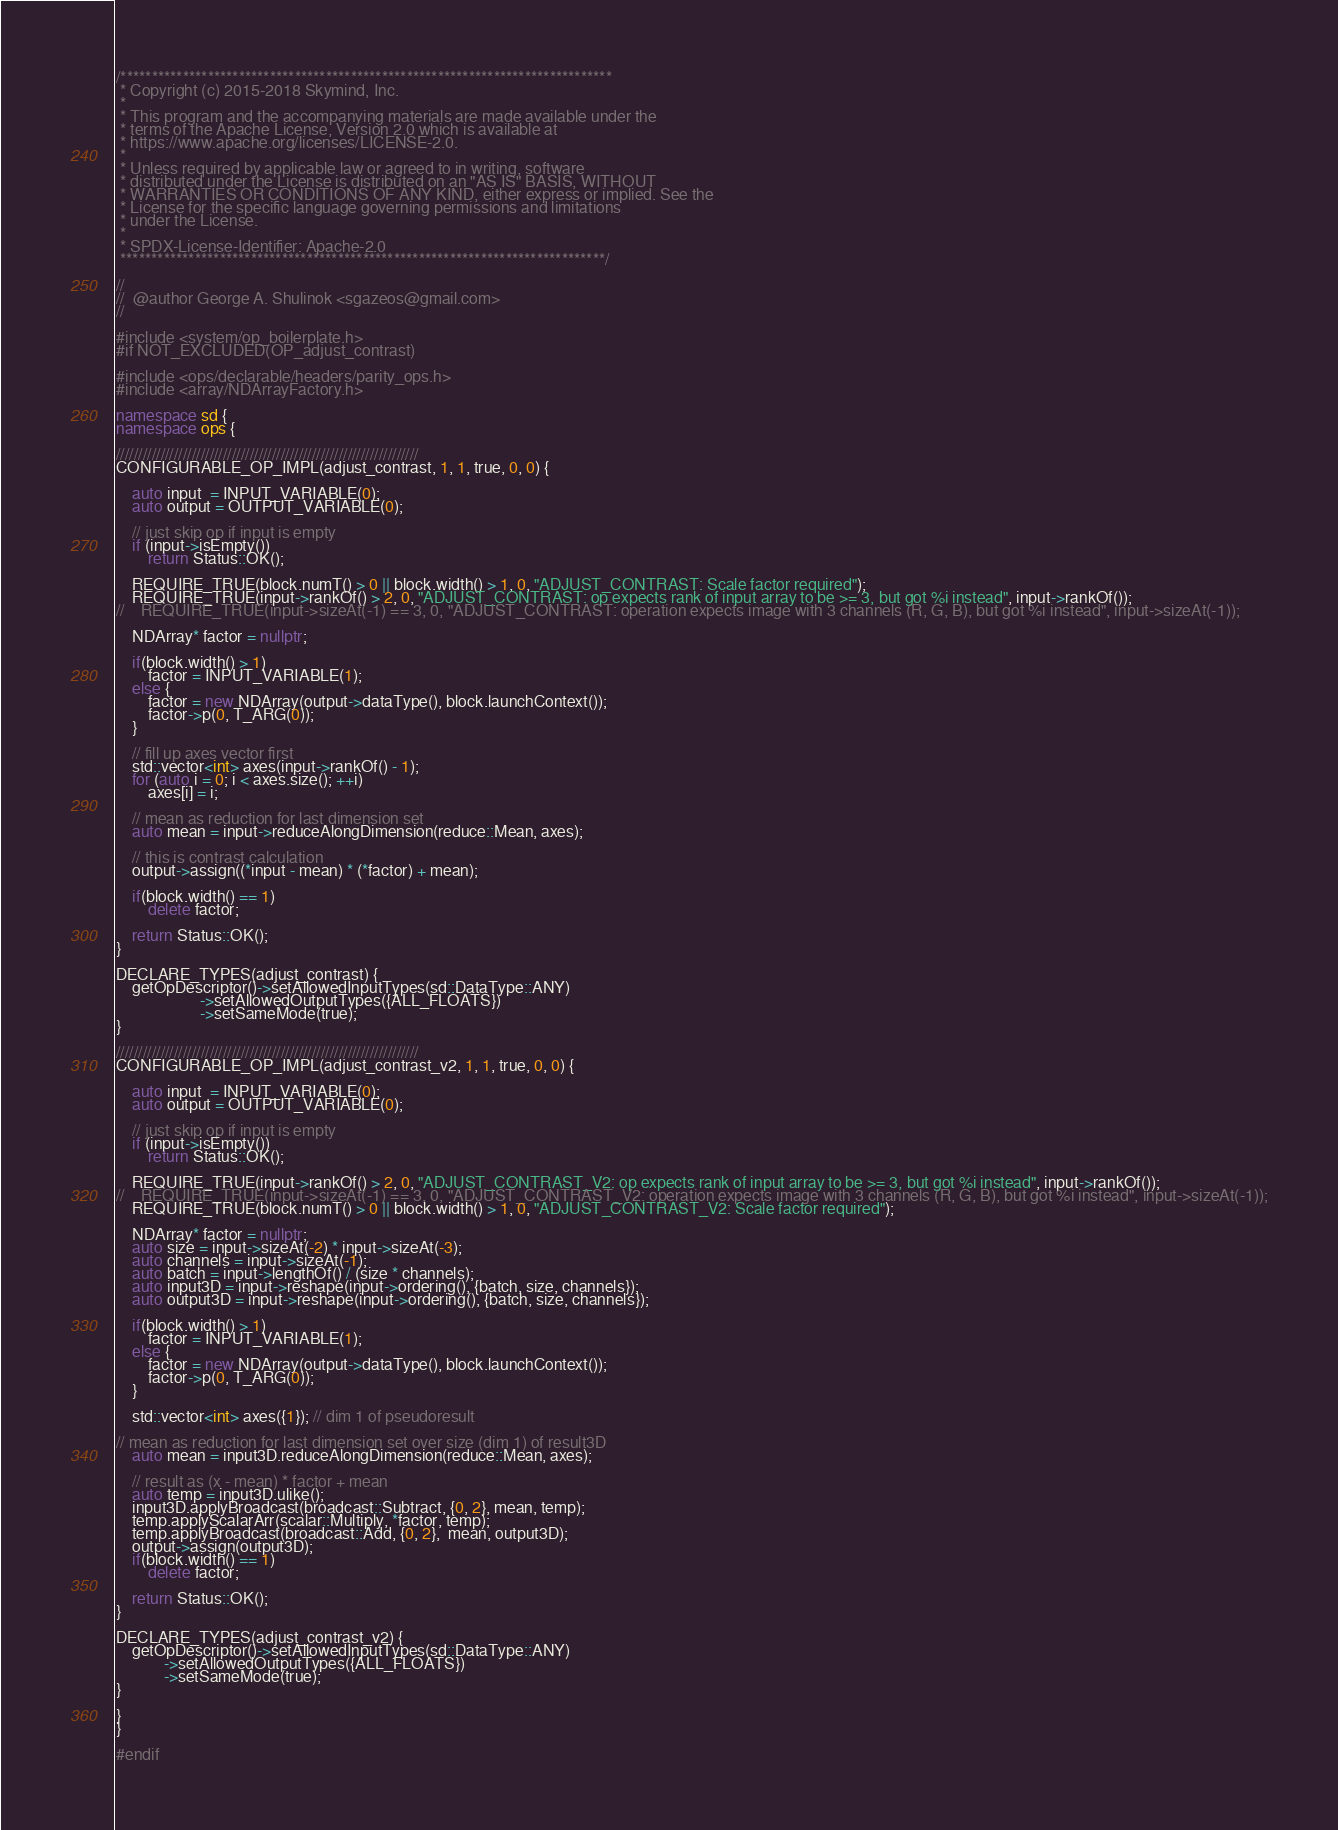Convert code to text. <code><loc_0><loc_0><loc_500><loc_500><_C++_>/*******************************************************************************
 * Copyright (c) 2015-2018 Skymind, Inc.
 *
 * This program and the accompanying materials are made available under the
 * terms of the Apache License, Version 2.0 which is available at
 * https://www.apache.org/licenses/LICENSE-2.0.
 *
 * Unless required by applicable law or agreed to in writing, software
 * distributed under the License is distributed on an "AS IS" BASIS, WITHOUT
 * WARRANTIES OR CONDITIONS OF ANY KIND, either express or implied. See the
 * License for the specific language governing permissions and limitations
 * under the License.
 *
 * SPDX-License-Identifier: Apache-2.0
 ******************************************************************************/

//
//  @author George A. Shulinok <sgazeos@gmail.com>
//

#include <system/op_boilerplate.h>
#if NOT_EXCLUDED(OP_adjust_contrast)

#include <ops/declarable/headers/parity_ops.h>
#include <array/NDArrayFactory.h>

namespace sd {
namespace ops {

////////////////////////////////////////////////////////////////////
CONFIGURABLE_OP_IMPL(adjust_contrast, 1, 1, true, 0, 0) {

    auto input  = INPUT_VARIABLE(0);
    auto output = OUTPUT_VARIABLE(0);

    // just skip op if input is empty
    if (input->isEmpty())
        return Status::OK();

    REQUIRE_TRUE(block.numT() > 0 || block.width() > 1, 0, "ADJUST_CONTRAST: Scale factor required");
    REQUIRE_TRUE(input->rankOf() > 2, 0, "ADJUST_CONTRAST: op expects rank of input array to be >= 3, but got %i instead", input->rankOf());
//    REQUIRE_TRUE(input->sizeAt(-1) == 3, 0, "ADJUST_CONTRAST: operation expects image with 3 channels (R, G, B), but got %i instead", input->sizeAt(-1));

    NDArray* factor = nullptr;

    if(block.width() > 1)
        factor = INPUT_VARIABLE(1);
    else {
        factor = new NDArray(output->dataType(), block.launchContext());
        factor->p(0, T_ARG(0));
    }

    // fill up axes vector first
    std::vector<int> axes(input->rankOf() - 1);
    for (auto i = 0; i < axes.size(); ++i)
        axes[i] = i;

    // mean as reduction for last dimension set
    auto mean = input->reduceAlongDimension(reduce::Mean, axes);

    // this is contrast calculation
    output->assign((*input - mean) * (*factor) + mean);

    if(block.width() == 1)
        delete factor;

    return Status::OK();
}

DECLARE_TYPES(adjust_contrast) {
    getOpDescriptor()->setAllowedInputTypes(sd::DataType::ANY)
                     ->setAllowedOutputTypes({ALL_FLOATS})
                     ->setSameMode(true);
}

////////////////////////////////////////////////////////////////////
CONFIGURABLE_OP_IMPL(adjust_contrast_v2, 1, 1, true, 0, 0) {

    auto input  = INPUT_VARIABLE(0);
    auto output = OUTPUT_VARIABLE(0);

    // just skip op if input is empty
    if (input->isEmpty())
        return Status::OK();

    REQUIRE_TRUE(input->rankOf() > 2, 0, "ADJUST_CONTRAST_V2: op expects rank of input array to be >= 3, but got %i instead", input->rankOf());
//    REQUIRE_TRUE(input->sizeAt(-1) == 3, 0, "ADJUST_CONTRAST_V2: operation expects image with 3 channels (R, G, B), but got %i instead", input->sizeAt(-1));
    REQUIRE_TRUE(block.numT() > 0 || block.width() > 1, 0, "ADJUST_CONTRAST_V2: Scale factor required");

    NDArray* factor = nullptr;
    auto size = input->sizeAt(-2) * input->sizeAt(-3);
    auto channels = input->sizeAt(-1);
    auto batch = input->lengthOf() / (size * channels);
    auto input3D = input->reshape(input->ordering(), {batch, size, channels});
    auto output3D = input->reshape(input->ordering(), {batch, size, channels});

    if(block.width() > 1)
        factor = INPUT_VARIABLE(1);
    else {
        factor = new NDArray(output->dataType(), block.launchContext());
        factor->p(0, T_ARG(0));
    }

    std::vector<int> axes({1}); // dim 1 of pseudoresult

// mean as reduction for last dimension set over size (dim 1) of result3D
    auto mean = input3D.reduceAlongDimension(reduce::Mean, axes);

    // result as (x - mean) * factor + mean
    auto temp = input3D.ulike();
    input3D.applyBroadcast(broadcast::Subtract, {0, 2}, mean, temp);
    temp.applyScalarArr(scalar::Multiply, *factor, temp);
    temp.applyBroadcast(broadcast::Add, {0, 2},  mean, output3D);
    output->assign(output3D);
    if(block.width() == 1)
        delete factor;

    return Status::OK();
}

DECLARE_TYPES(adjust_contrast_v2) {
    getOpDescriptor()->setAllowedInputTypes(sd::DataType::ANY)
            ->setAllowedOutputTypes({ALL_FLOATS})
            ->setSameMode(true);
}

}
}

#endif</code> 